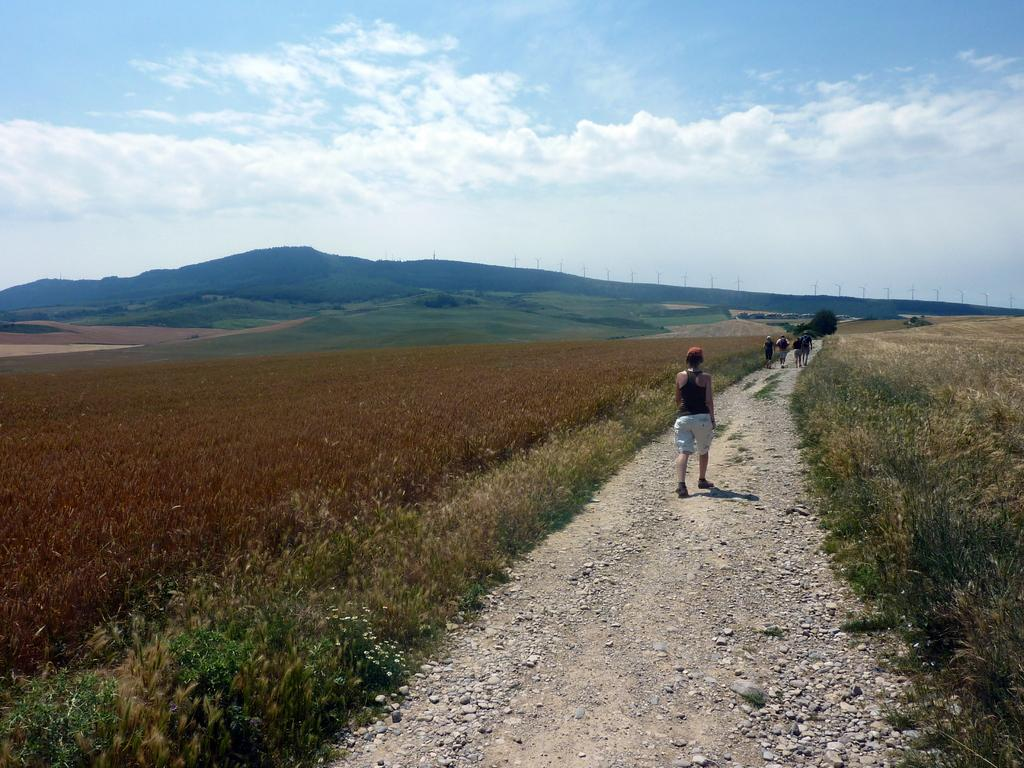What are the people in the image doing? The people in the image are walking on a path in the foreground. What type of vegetation is present alongside the path? There is grass on either side of the path. What can be seen in the background of the image? Grassland, cliffs, wind fans, and the sky are visible in the background of the image. How does the window in the image affect the view of the cliffs? There is no window present in the image; it features people walking on a path with grass on either side and various elements visible in the background, including cliffs. 